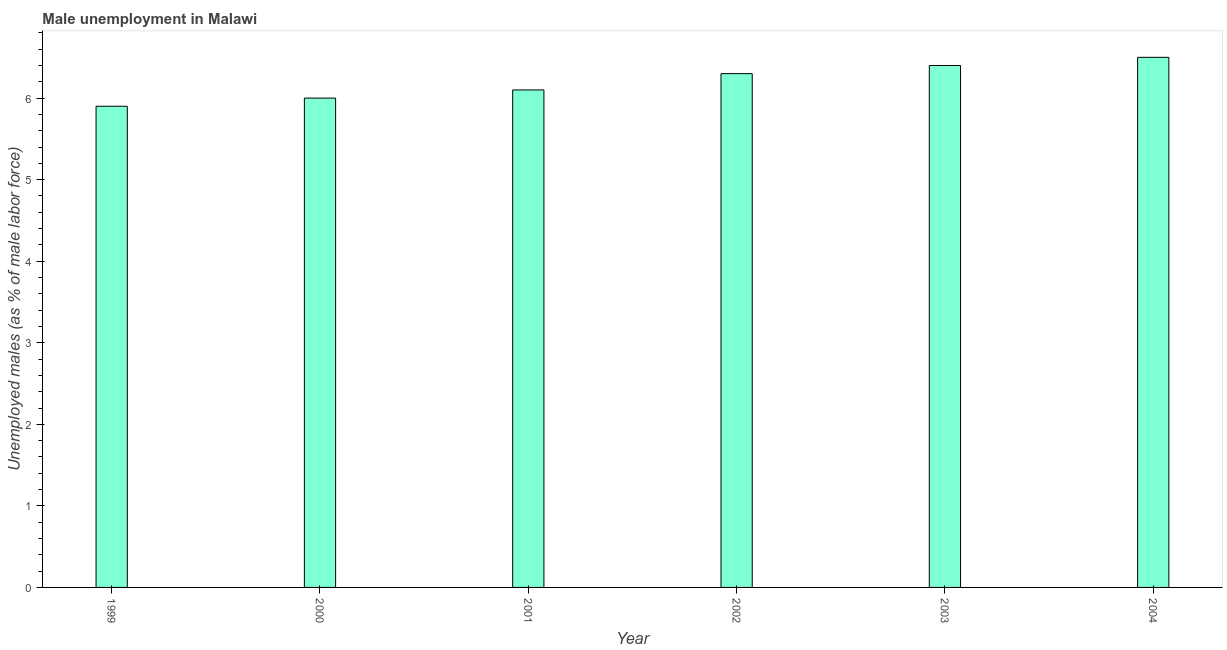Does the graph contain any zero values?
Ensure brevity in your answer.  No. What is the title of the graph?
Provide a short and direct response. Male unemployment in Malawi. What is the label or title of the X-axis?
Provide a succinct answer. Year. What is the label or title of the Y-axis?
Your response must be concise. Unemployed males (as % of male labor force). What is the unemployed males population in 2002?
Offer a terse response. 6.3. Across all years, what is the minimum unemployed males population?
Give a very brief answer. 5.9. What is the sum of the unemployed males population?
Provide a short and direct response. 37.2. What is the difference between the unemployed males population in 2003 and 2004?
Make the answer very short. -0.1. What is the average unemployed males population per year?
Offer a terse response. 6.2. What is the median unemployed males population?
Ensure brevity in your answer.  6.2. In how many years, is the unemployed males population greater than 4.2 %?
Your answer should be very brief. 6. Do a majority of the years between 2003 and 2001 (inclusive) have unemployed males population greater than 1.8 %?
Offer a very short reply. Yes. What is the ratio of the unemployed males population in 2000 to that in 2003?
Give a very brief answer. 0.94. Is the unemployed males population in 1999 less than that in 2001?
Offer a terse response. Yes. What is the difference between the highest and the second highest unemployed males population?
Offer a very short reply. 0.1. Is the sum of the unemployed males population in 2002 and 2003 greater than the maximum unemployed males population across all years?
Offer a very short reply. Yes. What is the difference between the highest and the lowest unemployed males population?
Your response must be concise. 0.6. How many years are there in the graph?
Offer a very short reply. 6. What is the difference between two consecutive major ticks on the Y-axis?
Provide a short and direct response. 1. Are the values on the major ticks of Y-axis written in scientific E-notation?
Offer a very short reply. No. What is the Unemployed males (as % of male labor force) in 1999?
Your answer should be compact. 5.9. What is the Unemployed males (as % of male labor force) of 2001?
Keep it short and to the point. 6.1. What is the Unemployed males (as % of male labor force) of 2002?
Offer a very short reply. 6.3. What is the Unemployed males (as % of male labor force) in 2003?
Ensure brevity in your answer.  6.4. What is the difference between the Unemployed males (as % of male labor force) in 1999 and 2004?
Provide a succinct answer. -0.6. What is the difference between the Unemployed males (as % of male labor force) in 2000 and 2003?
Keep it short and to the point. -0.4. What is the difference between the Unemployed males (as % of male labor force) in 2000 and 2004?
Give a very brief answer. -0.5. What is the difference between the Unemployed males (as % of male labor force) in 2001 and 2002?
Keep it short and to the point. -0.2. What is the difference between the Unemployed males (as % of male labor force) in 2001 and 2003?
Ensure brevity in your answer.  -0.3. What is the difference between the Unemployed males (as % of male labor force) in 2003 and 2004?
Provide a succinct answer. -0.1. What is the ratio of the Unemployed males (as % of male labor force) in 1999 to that in 2000?
Offer a very short reply. 0.98. What is the ratio of the Unemployed males (as % of male labor force) in 1999 to that in 2002?
Give a very brief answer. 0.94. What is the ratio of the Unemployed males (as % of male labor force) in 1999 to that in 2003?
Make the answer very short. 0.92. What is the ratio of the Unemployed males (as % of male labor force) in 1999 to that in 2004?
Provide a succinct answer. 0.91. What is the ratio of the Unemployed males (as % of male labor force) in 2000 to that in 2001?
Ensure brevity in your answer.  0.98. What is the ratio of the Unemployed males (as % of male labor force) in 2000 to that in 2003?
Give a very brief answer. 0.94. What is the ratio of the Unemployed males (as % of male labor force) in 2000 to that in 2004?
Offer a terse response. 0.92. What is the ratio of the Unemployed males (as % of male labor force) in 2001 to that in 2002?
Your response must be concise. 0.97. What is the ratio of the Unemployed males (as % of male labor force) in 2001 to that in 2003?
Your answer should be compact. 0.95. What is the ratio of the Unemployed males (as % of male labor force) in 2001 to that in 2004?
Give a very brief answer. 0.94. What is the ratio of the Unemployed males (as % of male labor force) in 2002 to that in 2004?
Keep it short and to the point. 0.97. 